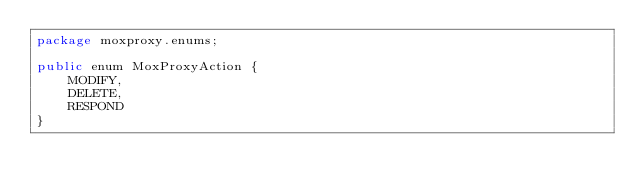<code> <loc_0><loc_0><loc_500><loc_500><_Java_>package moxproxy.enums;

public enum MoxProxyAction {
    MODIFY,
    DELETE,
    RESPOND
}
</code> 